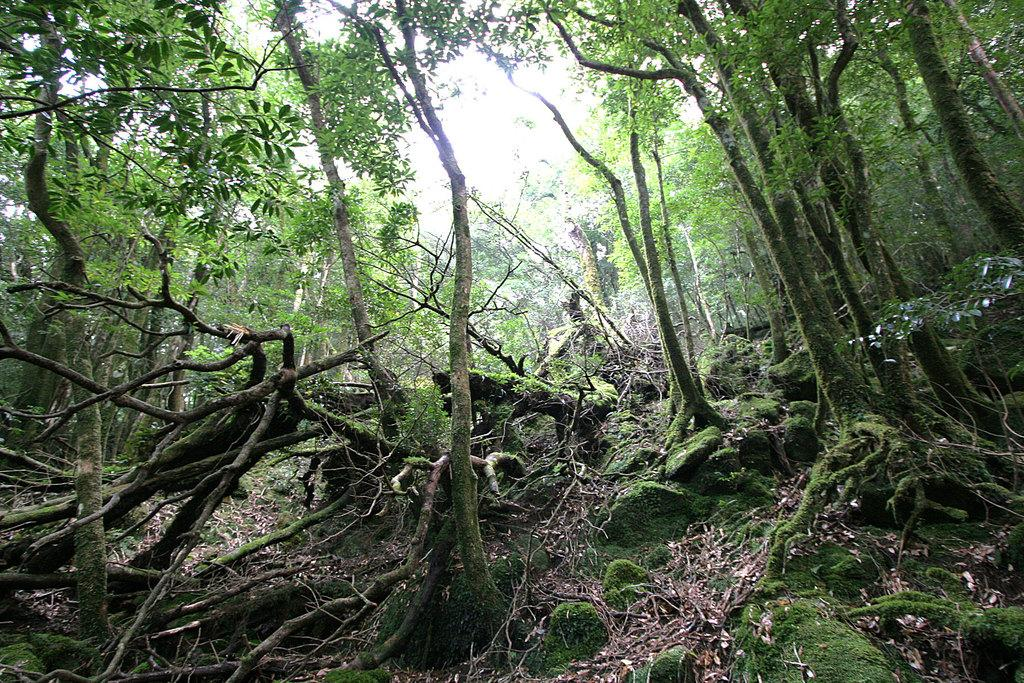What type of vegetation can be seen in the background of the image? There are trees in the background of the image. What is present at the bottom of the image? Dry leaves and algae are visible at the bottom of the image. What is visible at the top of the image? The sky is visible at the top of the image. What type of song can be heard in the background of the image? There is no song present in the image; it is a visual representation only. Can you describe the coastline visible in the image? There is no coastline visible in the image; it features trees, dry leaves, algae, and the sky. 